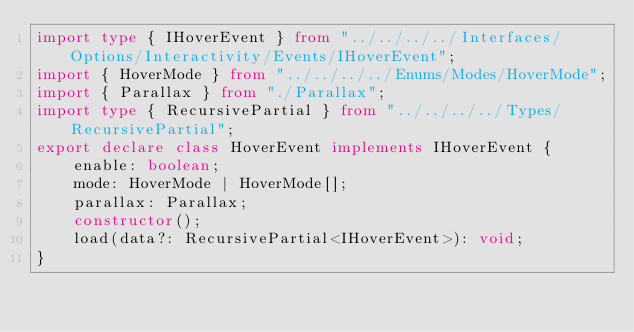Convert code to text. <code><loc_0><loc_0><loc_500><loc_500><_TypeScript_>import type { IHoverEvent } from "../../../../Interfaces/Options/Interactivity/Events/IHoverEvent";
import { HoverMode } from "../../../../Enums/Modes/HoverMode";
import { Parallax } from "./Parallax";
import type { RecursivePartial } from "../../../../Types/RecursivePartial";
export declare class HoverEvent implements IHoverEvent {
    enable: boolean;
    mode: HoverMode | HoverMode[];
    parallax: Parallax;
    constructor();
    load(data?: RecursivePartial<IHoverEvent>): void;
}
</code> 